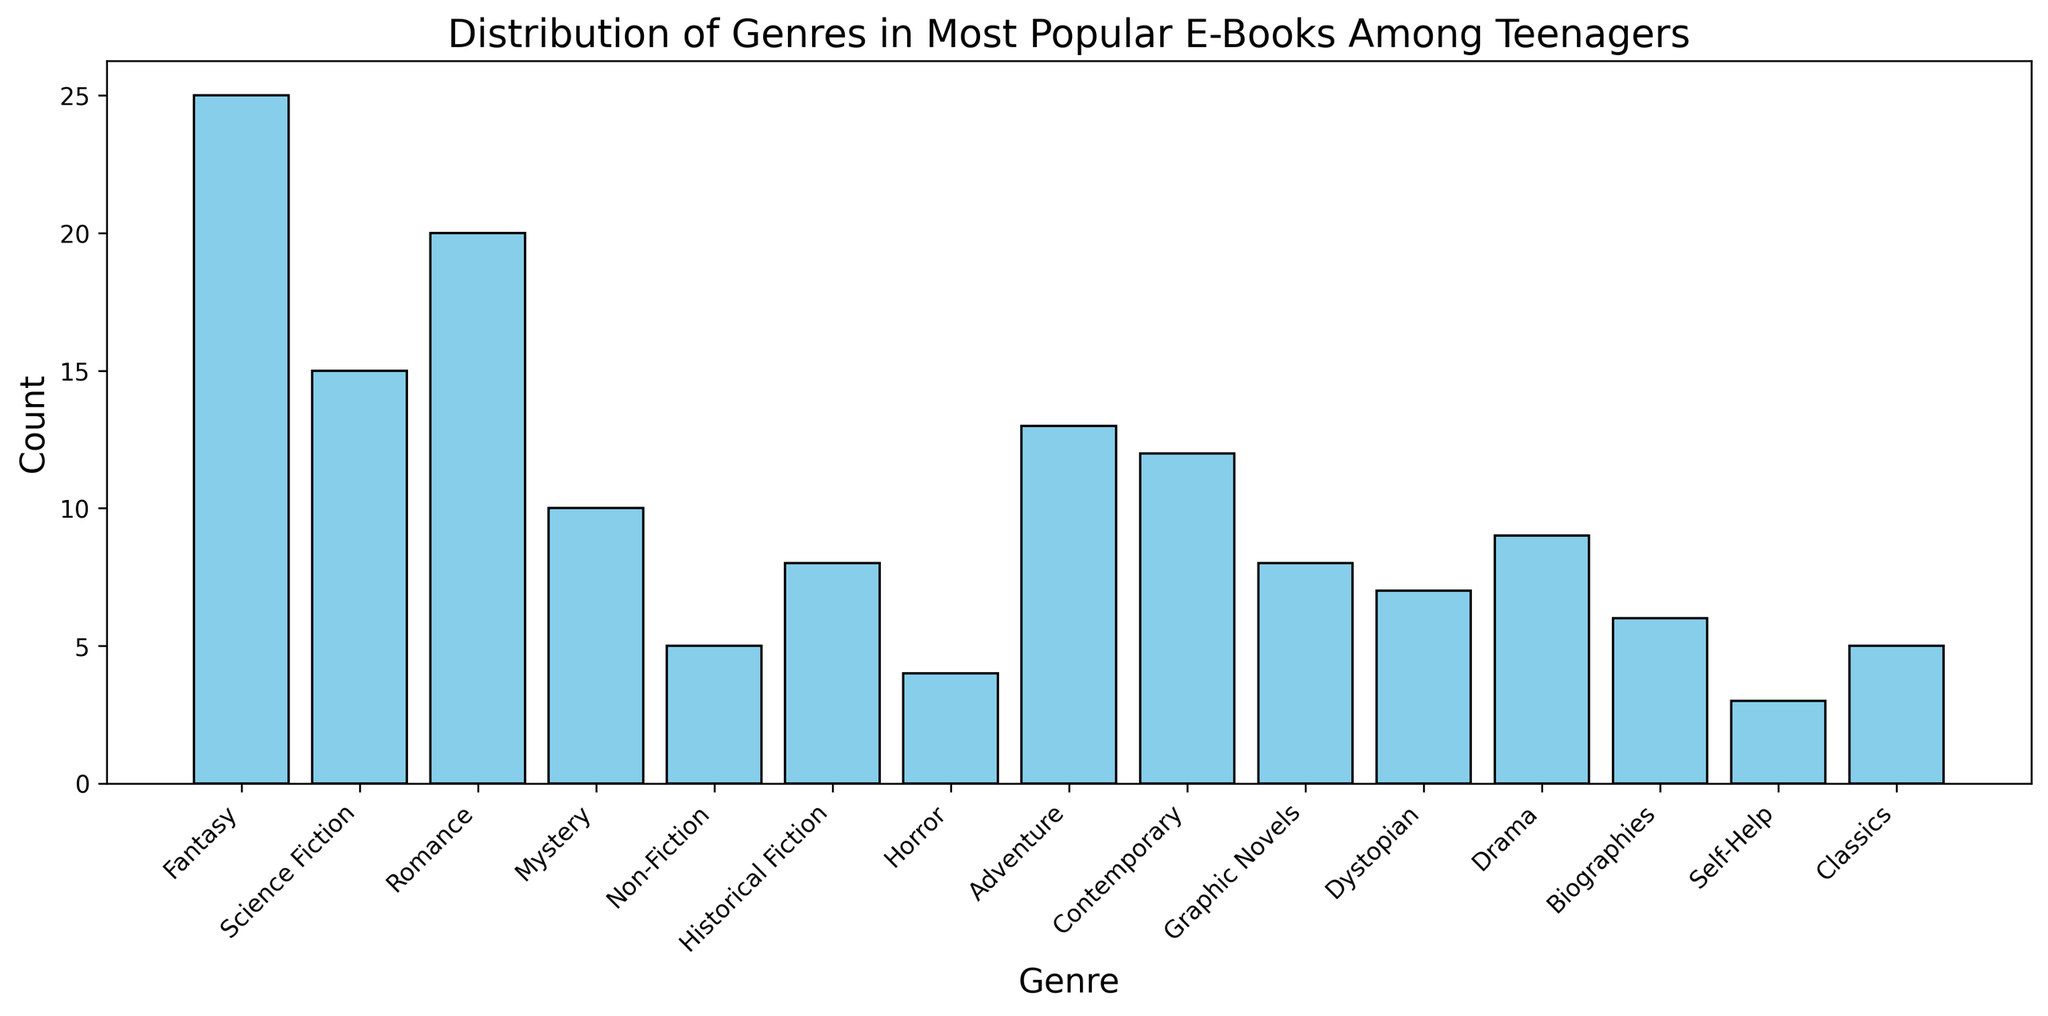Which genre has the highest count? By looking at the bars in the histogram, the tallest bar represents the genre with the highest count. Fantasy has the tallest bar, indicating it has the highest count.
Answer: Fantasy Which genre has the lowest popularity among teenagers? The shortest bar in the histogram corresponds to the genre with the lowest count. Self-Help has the shortest bar.
Answer: Self-Help What is the total count of Mystery and Drama genres combined? Locate the bars for Mystery and Drama: Mystery has a count of 10, and Drama has a count of 9. Add them together: 10 + 9 = 19.
Answer: 19 How many more popular books are there in the Fantasy genre compared to Science Fiction? Check the bars for Fantasy and Science Fiction: Fantasy has a count of 25, and Science Fiction has a count of 15. Subtract the count of Science Fiction from the count of Fantasy: 25 - 15 = 10.
Answer: 10 Which genre has a taller bar, Adventure or Contemporary? Compare the heights of the bars for Adventure and Contemporary: Adventure has a higher count of 13 compared to Contemporary's 12.
Answer: Adventure Is Romance more popular than Dystopian? Look at the bars for Romance and Dystopian: Romance has a count of 20, while Dystopian has a count of 7. Since 20 is greater than 7, Romance is more popular.
Answer: Yes What’s the sum of counts for Non-Fiction, Biographies, and Classics? Add the counts of Non-Fiction (5), Biographies (6), and Classics (5): 5 + 6 + 5 = 16.
Answer: 16 Which genres have a count greater than 10? Identify the bars with counts higher than 10. These genres are Fantasy (25), Science Fiction (15), Romance (20), Adventure (13), and Contemporary (12).
Answer: Fantasy, Science Fiction, Romance, Adventure, Contemporary What is the difference in count between the Historical Fiction and Graphic Novels genres? Subtract the count of Graphic Novels (8) from the count of Historical Fiction (8): 8 - 8 = 0.
Answer: 0 Which genre is equally popular to Graphic Novels? Determine which other genre has the same count as Graphic Novels, which is 8. Historical Fiction also has a count of 8.
Answer: Historical Fiction 